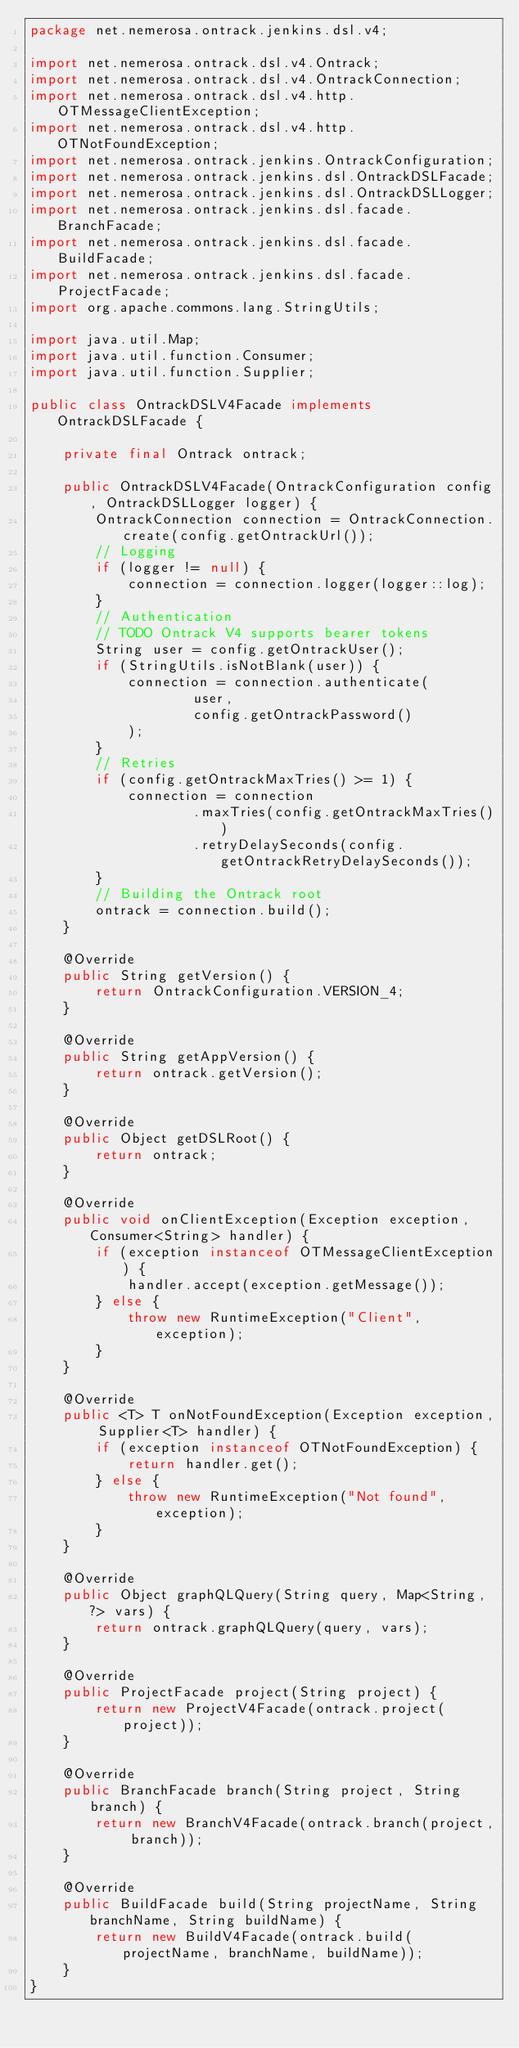Convert code to text. <code><loc_0><loc_0><loc_500><loc_500><_Java_>package net.nemerosa.ontrack.jenkins.dsl.v4;

import net.nemerosa.ontrack.dsl.v4.Ontrack;
import net.nemerosa.ontrack.dsl.v4.OntrackConnection;
import net.nemerosa.ontrack.dsl.v4.http.OTMessageClientException;
import net.nemerosa.ontrack.dsl.v4.http.OTNotFoundException;
import net.nemerosa.ontrack.jenkins.OntrackConfiguration;
import net.nemerosa.ontrack.jenkins.dsl.OntrackDSLFacade;
import net.nemerosa.ontrack.jenkins.dsl.OntrackDSLLogger;
import net.nemerosa.ontrack.jenkins.dsl.facade.BranchFacade;
import net.nemerosa.ontrack.jenkins.dsl.facade.BuildFacade;
import net.nemerosa.ontrack.jenkins.dsl.facade.ProjectFacade;
import org.apache.commons.lang.StringUtils;

import java.util.Map;
import java.util.function.Consumer;
import java.util.function.Supplier;

public class OntrackDSLV4Facade implements OntrackDSLFacade {

    private final Ontrack ontrack;

    public OntrackDSLV4Facade(OntrackConfiguration config, OntrackDSLLogger logger) {
        OntrackConnection connection = OntrackConnection.create(config.getOntrackUrl());
        // Logging
        if (logger != null) {
            connection = connection.logger(logger::log);
        }
        // Authentication
        // TODO Ontrack V4 supports bearer tokens
        String user = config.getOntrackUser();
        if (StringUtils.isNotBlank(user)) {
            connection = connection.authenticate(
                    user,
                    config.getOntrackPassword()
            );
        }
        // Retries
        if (config.getOntrackMaxTries() >= 1) {
            connection = connection
                    .maxTries(config.getOntrackMaxTries())
                    .retryDelaySeconds(config.getOntrackRetryDelaySeconds());
        }
        // Building the Ontrack root
        ontrack = connection.build();
    }

    @Override
    public String getVersion() {
        return OntrackConfiguration.VERSION_4;
    }

    @Override
    public String getAppVersion() {
        return ontrack.getVersion();
    }

    @Override
    public Object getDSLRoot() {
        return ontrack;
    }

    @Override
    public void onClientException(Exception exception, Consumer<String> handler) {
        if (exception instanceof OTMessageClientException) {
            handler.accept(exception.getMessage());
        } else {
            throw new RuntimeException("Client", exception);
        }
    }

    @Override
    public <T> T onNotFoundException(Exception exception, Supplier<T> handler) {
        if (exception instanceof OTNotFoundException) {
            return handler.get();
        } else {
            throw new RuntimeException("Not found", exception);
        }
    }

    @Override
    public Object graphQLQuery(String query, Map<String, ?> vars) {
        return ontrack.graphQLQuery(query, vars);
    }

    @Override
    public ProjectFacade project(String project) {
        return new ProjectV4Facade(ontrack.project(project));
    }

    @Override
    public BranchFacade branch(String project, String branch) {
        return new BranchV4Facade(ontrack.branch(project, branch));
    }

    @Override
    public BuildFacade build(String projectName, String branchName, String buildName) {
        return new BuildV4Facade(ontrack.build(projectName, branchName, buildName));
    }
}
</code> 